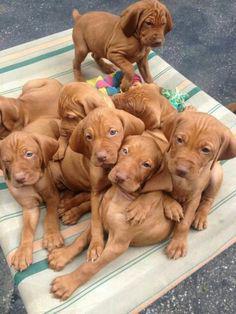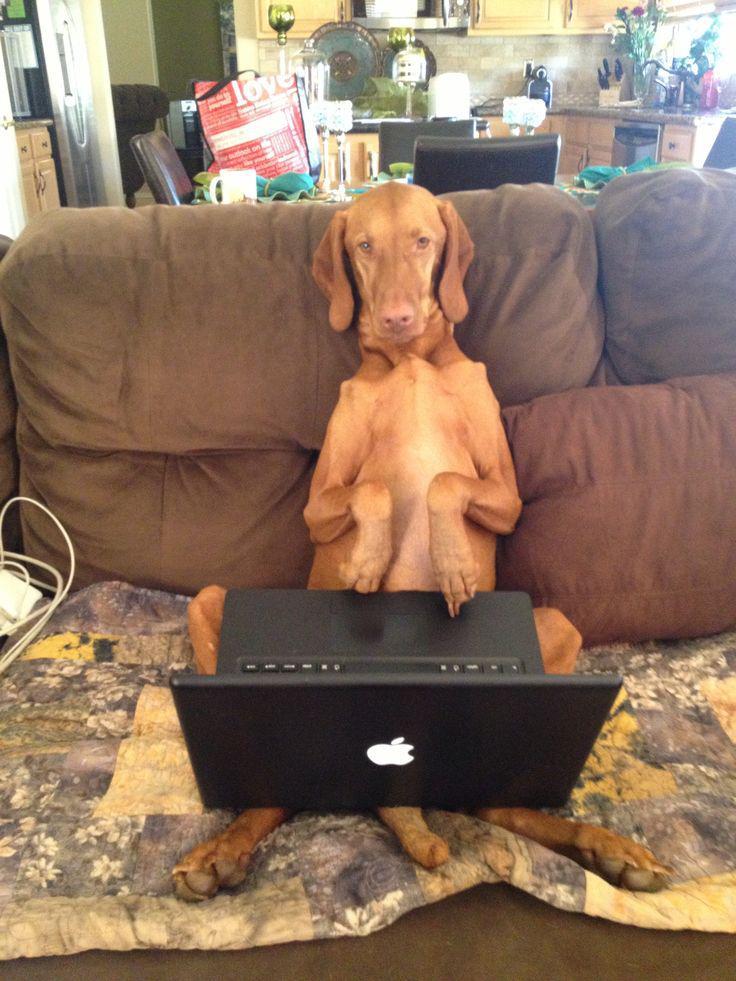The first image is the image on the left, the second image is the image on the right. Considering the images on both sides, is "In one image, a dog's upright head and shoulders are behind a squarish flat surface which its front paws are over." valid? Answer yes or no. Yes. 